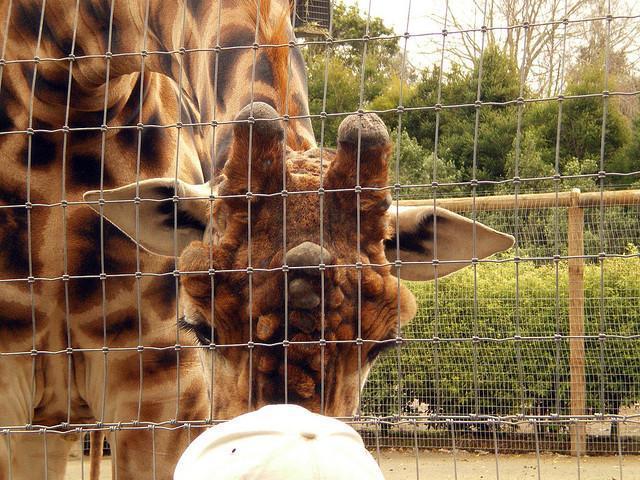How many elephants are there in total?
Give a very brief answer. 0. 